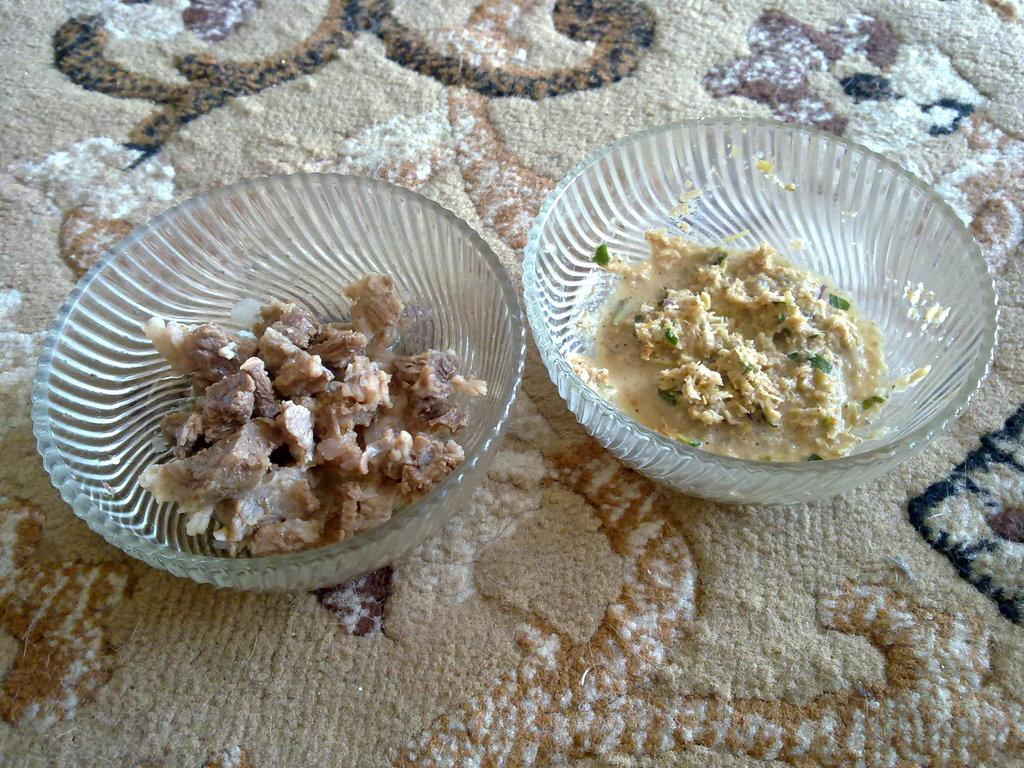How many glass bowls are visible in the image? There are two glass bowls in the image. What is inside the glass bowls? There are food items in the bowls. Where are the glass bowls placed? The bowls are on a colorful blanket. What type of industry is depicted on the colorful blanket in the image? There is no industry depicted on the colorful blanket in the image. What material is the calculator made of in the image? There is no calculator present in the image. 